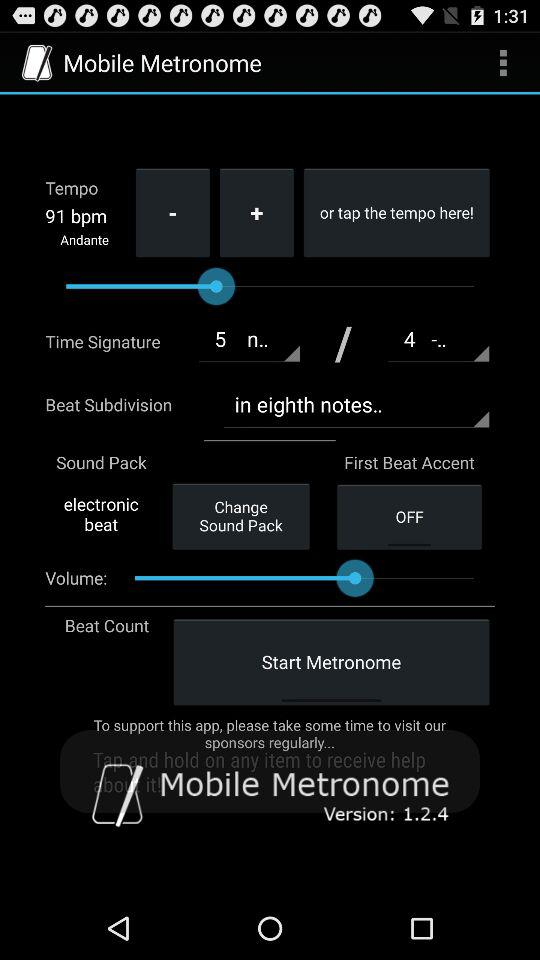What is the tempo? The tempo is 91 beats per minute. 